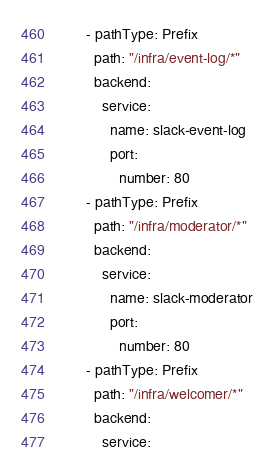<code> <loc_0><loc_0><loc_500><loc_500><_YAML_>      - pathType: Prefix
        path: "/infra/event-log/*"
        backend:
          service:
            name: slack-event-log
            port:
              number: 80
      - pathType: Prefix
        path: "/infra/moderator/*"
        backend:
          service:
            name: slack-moderator
            port:
              number: 80
      - pathType: Prefix
        path: "/infra/welcomer/*"
        backend:
          service:</code> 